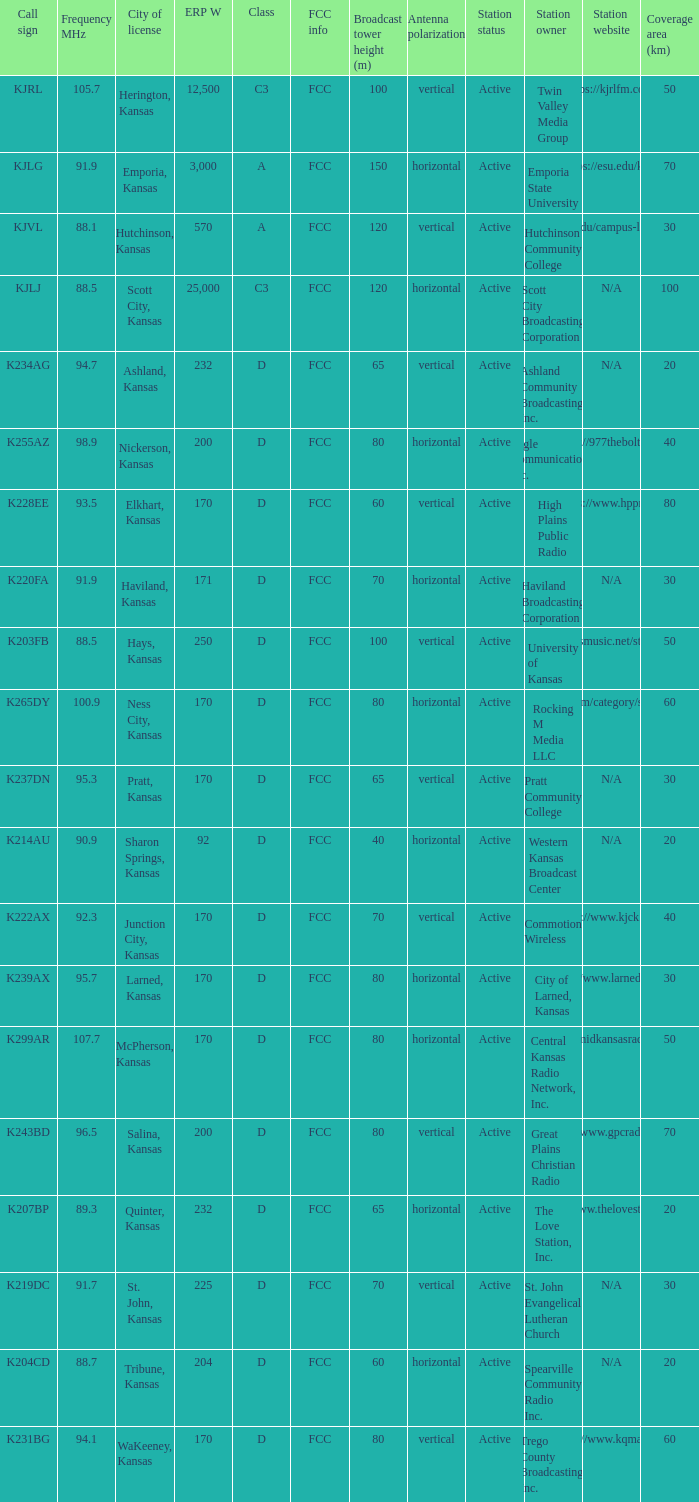Class of d, and a Frequency MHz smaller than 107.7, and a ERP W smaller than 232 has what call sign? K255AZ, K228EE, K220FA, K265DY, K237DN, K214AU, K222AX, K239AX, K243BD, K219DC, K204CD, K231BG. 